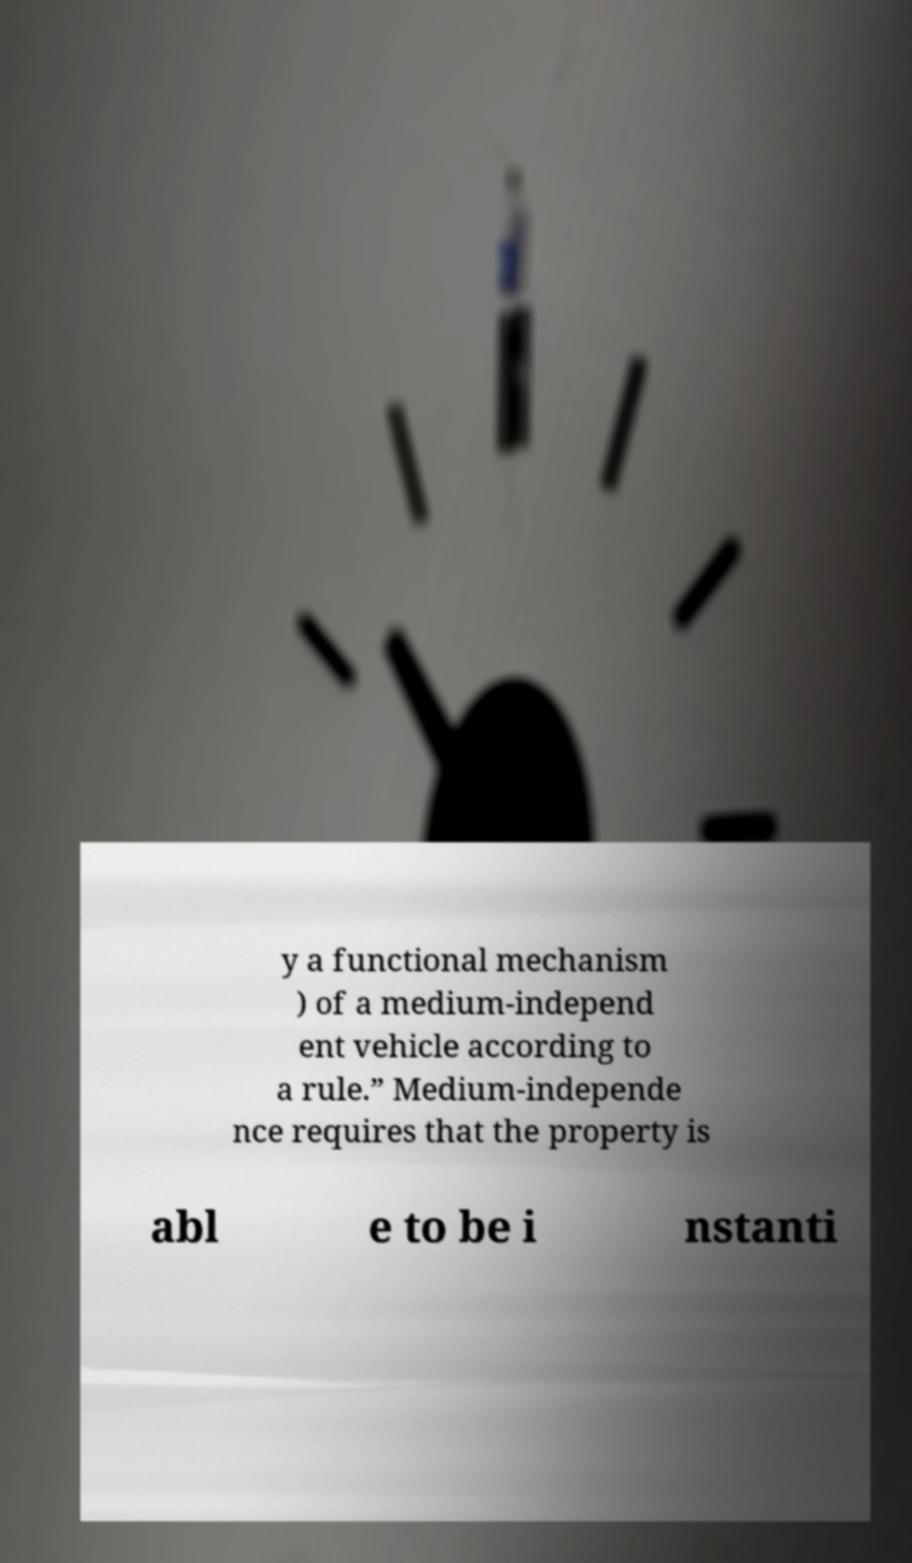Can you accurately transcribe the text from the provided image for me? y a functional mechanism ) of a medium-independ ent vehicle according to a rule.” Medium-independe nce requires that the property is abl e to be i nstanti 